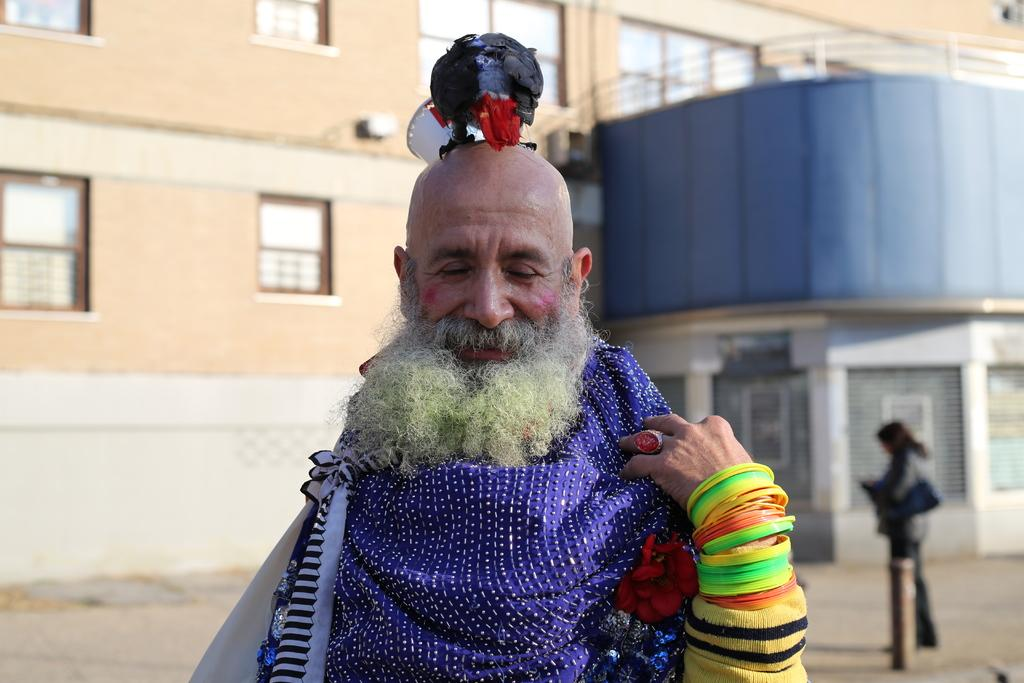Who or what is the main subject in the image? There is a person in the image. What other living creature can be seen in the image? There is a bird in the image. Can you describe the background of the image? There is another person in the background of the image, and there is also a building in the background. What type of sugar is being used to plough the field in the image? There is no field or ploughing activity present in the image. 